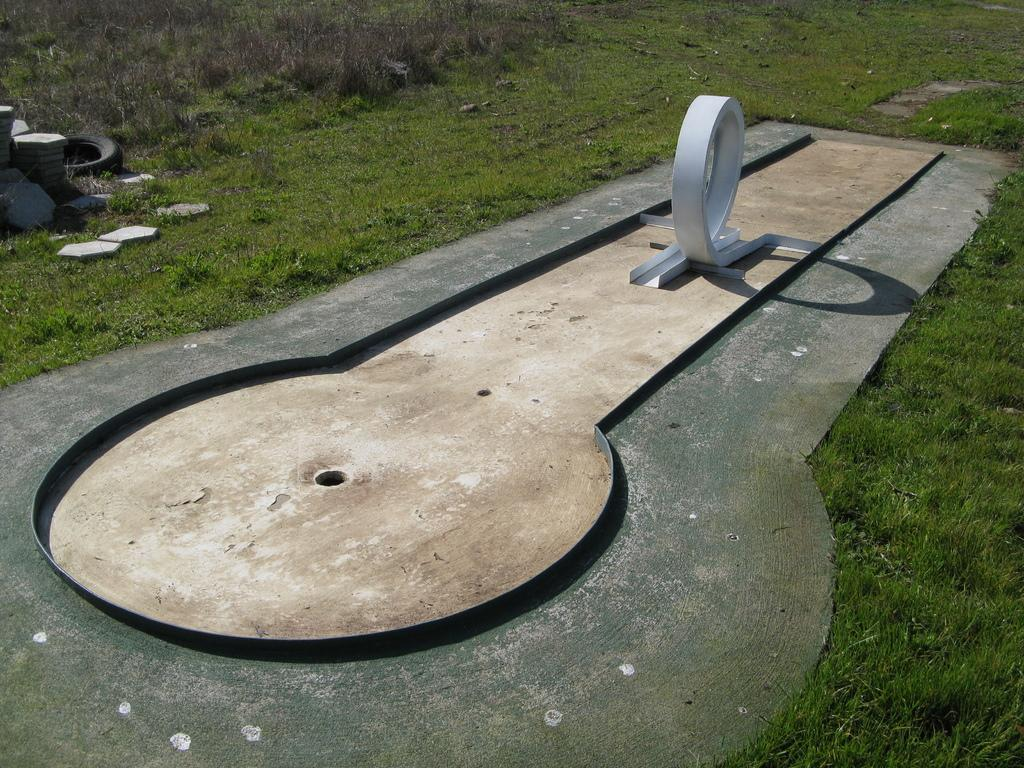What type of vegetation is present in the center of the image? There is grass in the center of the image. What other objects can be seen in the center of the image? There are stones, a tire, and a key-shaped object in the center of the image. How does the grass express regret in the image? The grass does not express regret in the image, as it is a non-living object and cannot experience emotions. 